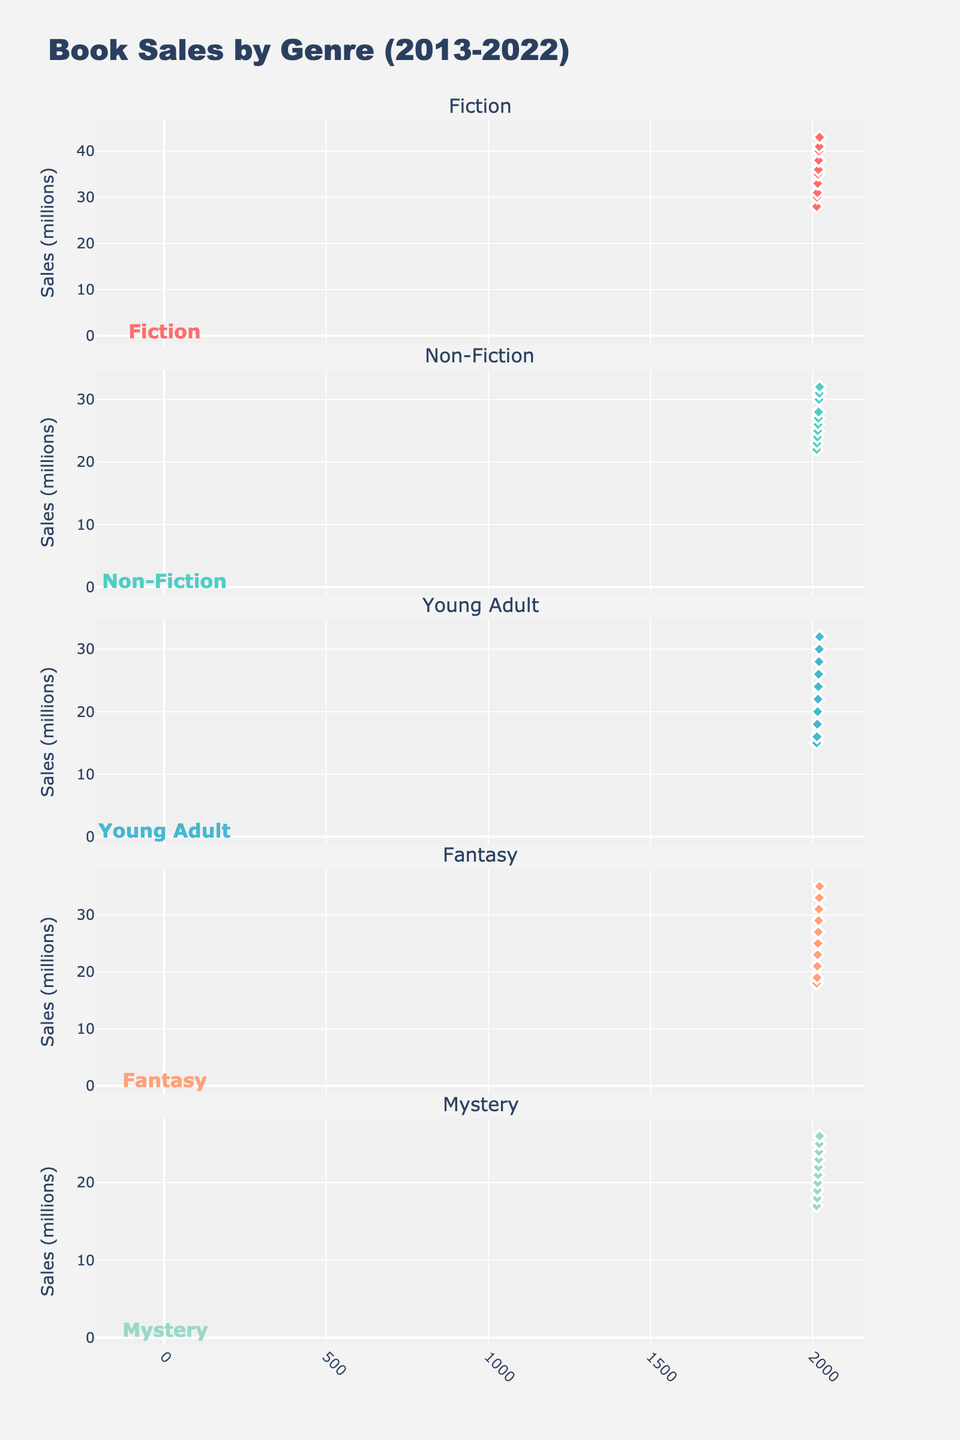What is the title of the figure? The title is displayed at the top of the figure and provides an overview of the data being visualized. In this case, the title reads, "Book Sales by Genre (2013-2022)."
Answer: Book Sales by Genre (2013-2022) How many genres are represented in the subplots? By counting the subplot titles or the number of traces in the figure, we find there are five genres represented. These genres can be seen in the individual subplot titles.
Answer: 5 Which genre had the highest sales in 2022? We look at the data points for the year 2022 across all subplots. The highest value is in the Fiction subplot, which shows 43 million sales.
Answer: Fiction What was the sales trend for Fantasy genre from 2013 to 2022? Observe the trend line in the Fantasy subplot. The sales increase steadily over the years, starting at 18 million in 2013 and reaching 35 million in 2022.
Answer: Increasing What is the average annual sales of Mystery books over the decade? First, add up the annual sales data for Mystery (17 + 18 + 19 + 20 + 21 + 22 + 23 + 24 + 25 + 26). The total is 215. Divide this by the number of years (10) to find the average.
Answer: 21.5 million Which genre had the lowest sales in 2016, and what was the value? Look at the year 2016 across all subplots. The lowest value among them is in the Young Adult subplot which shows 20 million sales.
Answer: Young Adult, 20 million By how much did Non-Fiction sales increase from 2018 to 2022? Find the sales of Non-Fiction in 2018 (27 million) and 2022 (32 million). Subtract the former from the latter to find the increase: 32 - 27 = 5 million.
Answer: 5 million Compare the Fiction and Young Adult sales in 2017. Which genre had higher sales and by how much? In 2017, Fiction sales were 35 million and Young Adult sales were 22 million. The difference is 35 - 22 = 13 million. Fiction had higher sales by 13 million.
Answer: Fiction, 13 million What linear pattern can be inferred from the subplots over the decade for any genre? Each subplot shows a consistent linear increase in sales numbers over the years from 2013 to 2022. This indicates a steady growth trend for all genres.
Answer: Steady linear growth How does the sales growth of Fiction compare to Fantasy over the decade? Both subplots show an increasing trend, but examining the y-values, Fiction starts at 28 million and ends at 43 million (15 million increase), while Fantasy starts at 18 million and ends at 35 million (17 million increase). Though both grew, Fantasy had a slightly higher absolute increase.
Answer: Both increased, Fantasy had a greater absolute increase 